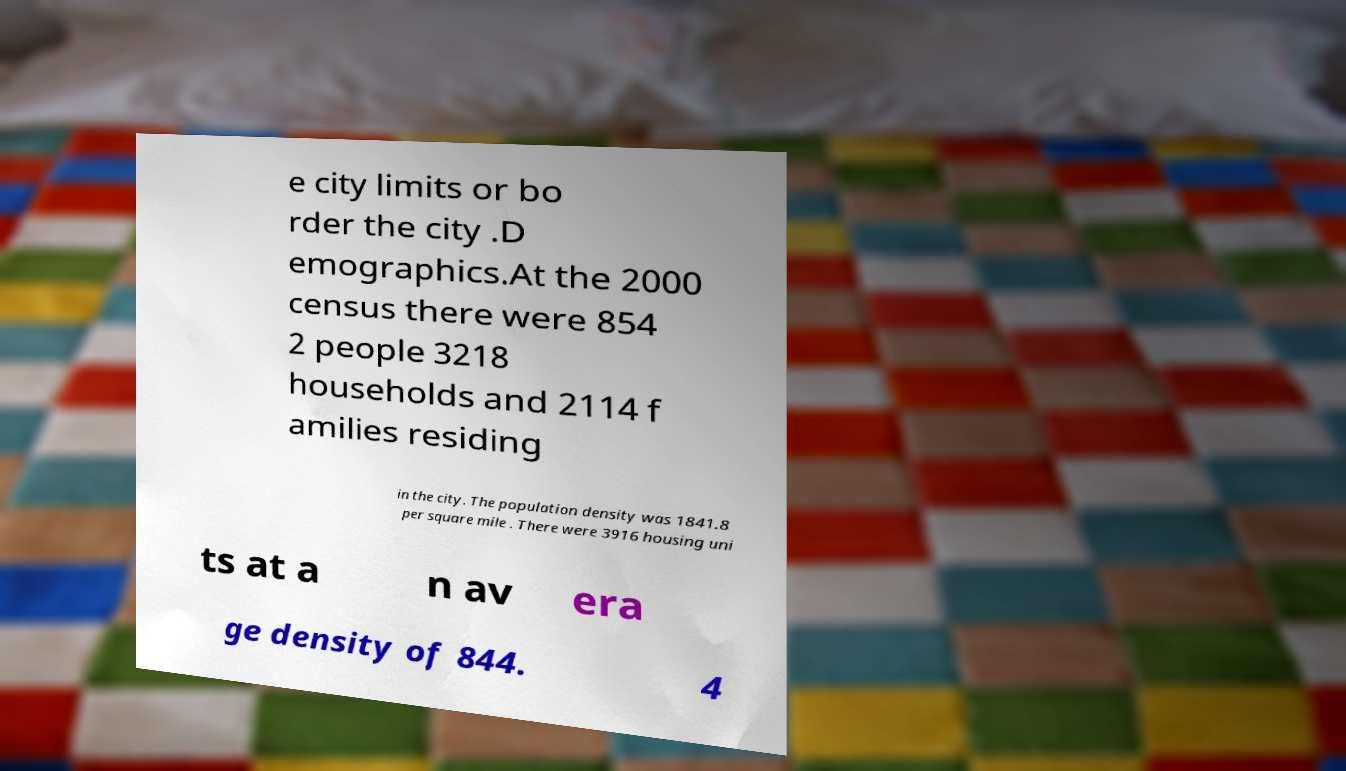Can you read and provide the text displayed in the image?This photo seems to have some interesting text. Can you extract and type it out for me? e city limits or bo rder the city .D emographics.At the 2000 census there were 854 2 people 3218 households and 2114 f amilies residing in the city. The population density was 1841.8 per square mile . There were 3916 housing uni ts at a n av era ge density of 844. 4 